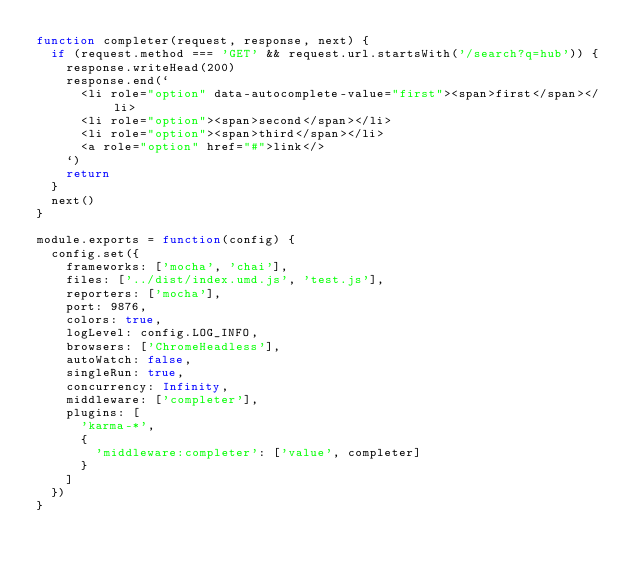Convert code to text. <code><loc_0><loc_0><loc_500><loc_500><_JavaScript_>function completer(request, response, next) {
  if (request.method === 'GET' && request.url.startsWith('/search?q=hub')) {
    response.writeHead(200)
    response.end(`
      <li role="option" data-autocomplete-value="first"><span>first</span></li>
      <li role="option"><span>second</span></li>
      <li role="option"><span>third</span></li>
      <a role="option" href="#">link</>
    `)
    return
  }
  next()
}

module.exports = function(config) {
  config.set({
    frameworks: ['mocha', 'chai'],
    files: ['../dist/index.umd.js', 'test.js'],
    reporters: ['mocha'],
    port: 9876,
    colors: true,
    logLevel: config.LOG_INFO,
    browsers: ['ChromeHeadless'],
    autoWatch: false,
    singleRun: true,
    concurrency: Infinity,
    middleware: ['completer'],
    plugins: [
      'karma-*',
      {
        'middleware:completer': ['value', completer]
      }
    ]
  })
}
</code> 